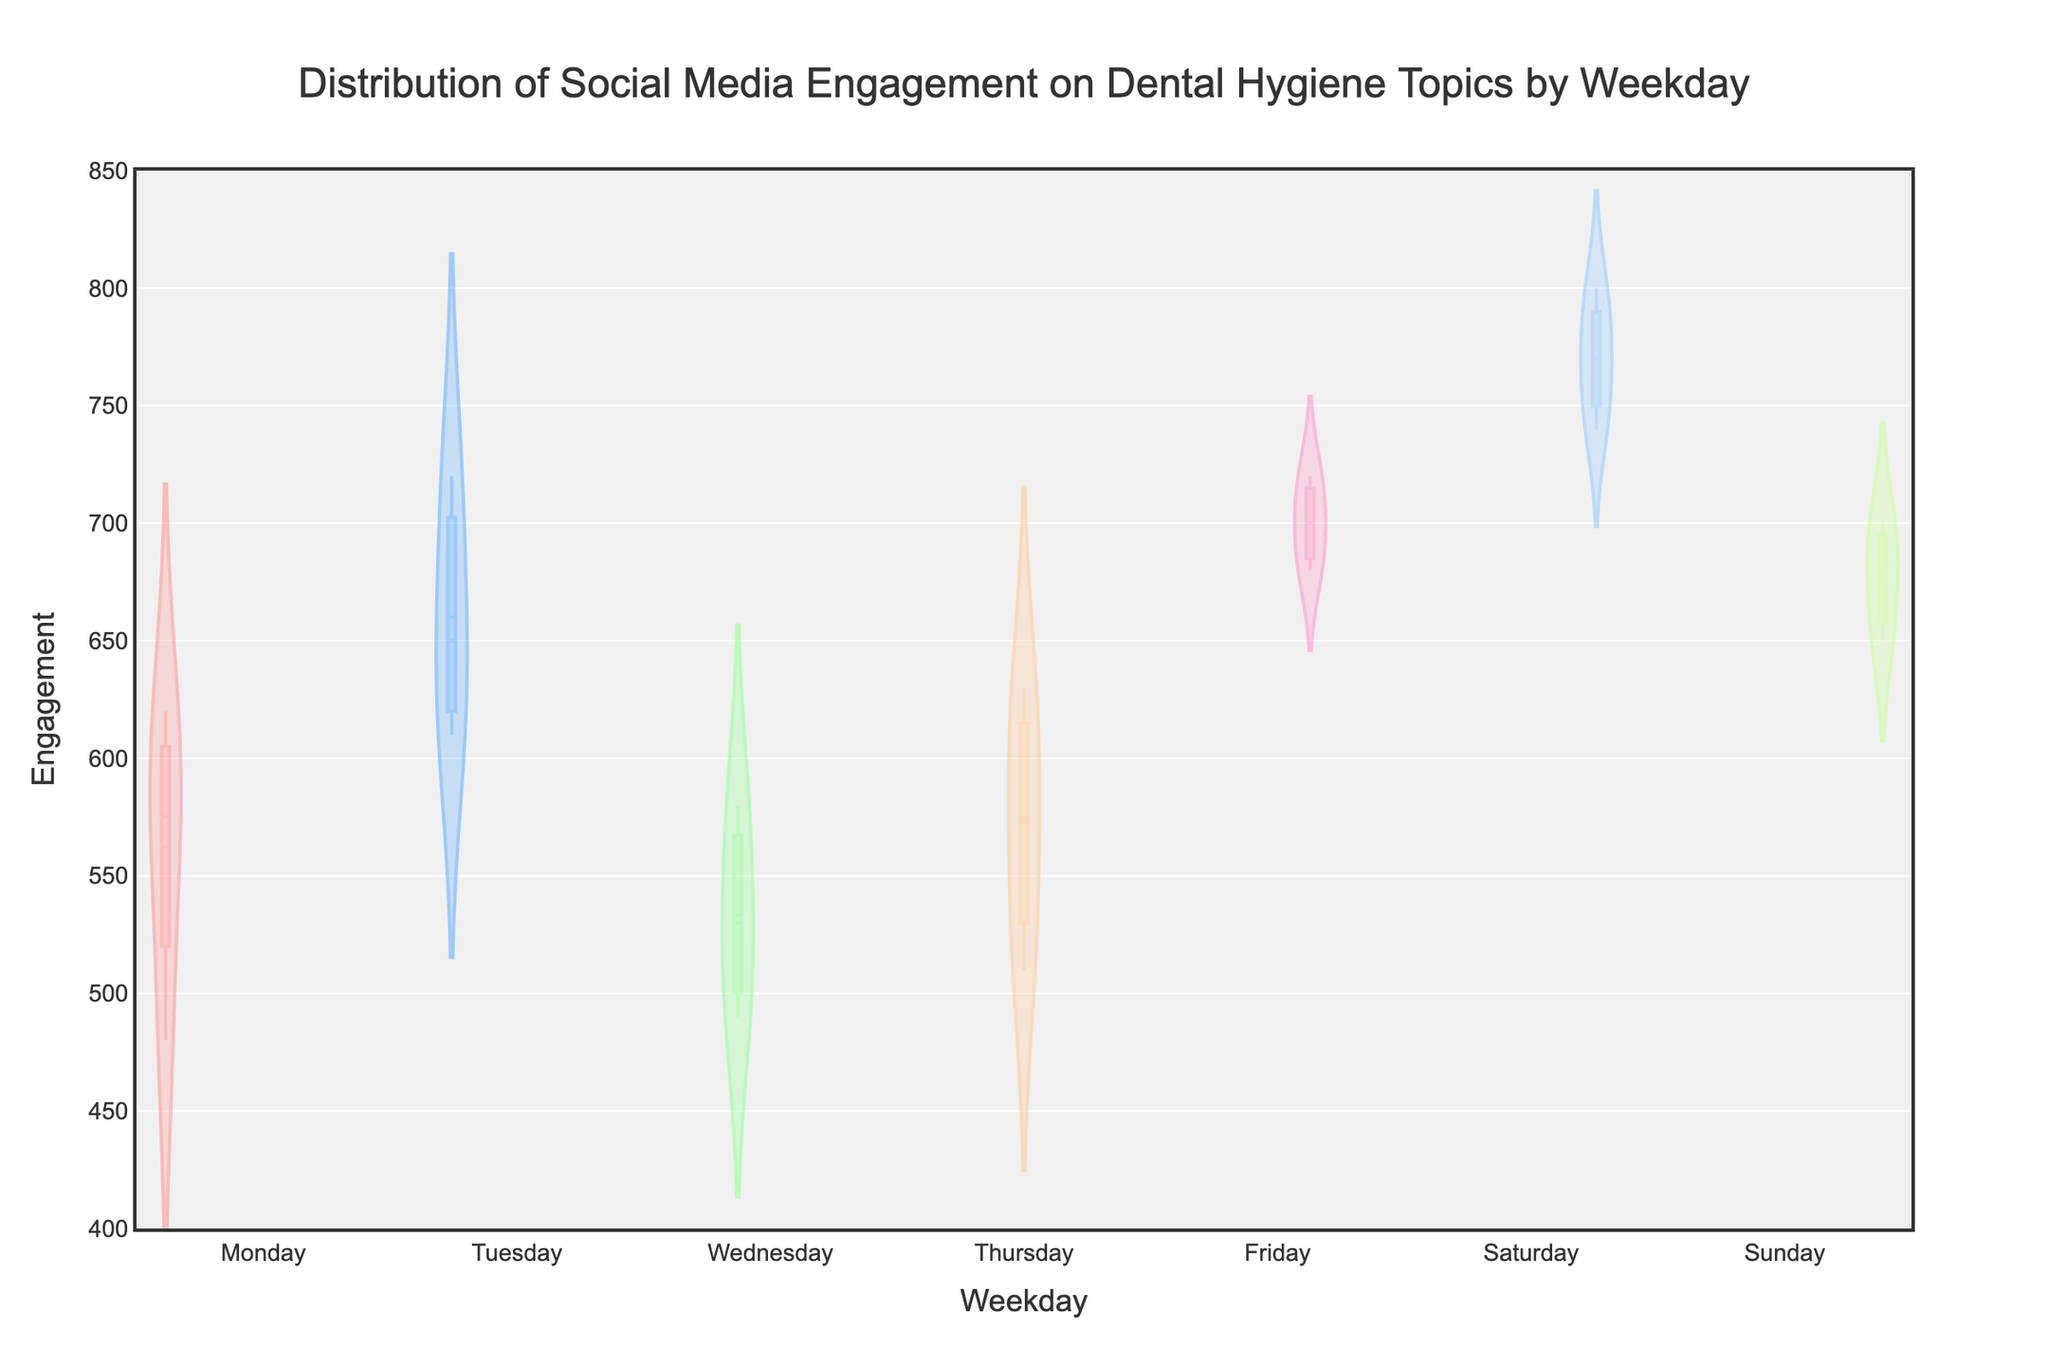What is the title of the plot? The title is written at the top of the figure and usually describes what the plot is about. In this case, it is clearly stated.
Answer: Distribution of Social Media Engagement on Dental Hygiene Topics by Weekday Which weekday shows the highest maximum engagement? Look at the highest points for each density plot (the shape of the violin plot) and note which day has the highest. Saturday has the highest point.
Answer: Saturday What is the range of engagement values shown on the y-axis? The y-axis visually displays the range covered by engagement values. Here, it starts at 400 and goes up to 850 as specified in the y-axis settings.
Answer: 400 to 850 Which weekday has the smallest spread of engagement values? The spread of engagement values can be seen from the width of the violin plots. The narrowest plot corresponds to the smallest spread. Wednesday's plot appears to have the smallest spread.
Answer: Wednesday Is the mean engagement value for Thursdays higher or lower than for Fridays? The mean engagement is indicated by the horizontal mean line on each violin plot. Compare the mean line for Thursday with that of Friday to determine their relative positions.
Answer: Lower How does the engagement on Sundays compare to Saturdays in terms of spread? Compare the widths of the violin plots for Saturday and Sunday. A wider plot indicates a larger spread of engagement values. Saturday's plot is wider.
Answer: Saturday's spread is larger What color represents Tuesday's data? Each weekday is represented by a different color. The color for Tuesday is toward the start of the color list provided. Tuesday is the second day, so it uses the second color.
Answer: Blue (#66B2FF) What's the median engagement value for Mondays? The median is the point that divides the data into two equal halves and can be visually estimated from the middle line inside the box of the violin plot. For Monday, it is slightly above the middle of the y-axis range.
Answer: Approximately 590 Which weekday has the visually highest density of high engagement? Violin plots that are wider at the upper end of the y-axis show higher density of high engagement values. Saturday's plot is widest at the upper end.
Answer: Saturday On which days does the engagement typically exceed 700? Look at where the violin plots extend above the 700-mark on the y-axis. Friday and Saturday have substantial portions of their plots above 700.
Answer: Friday and Saturday 